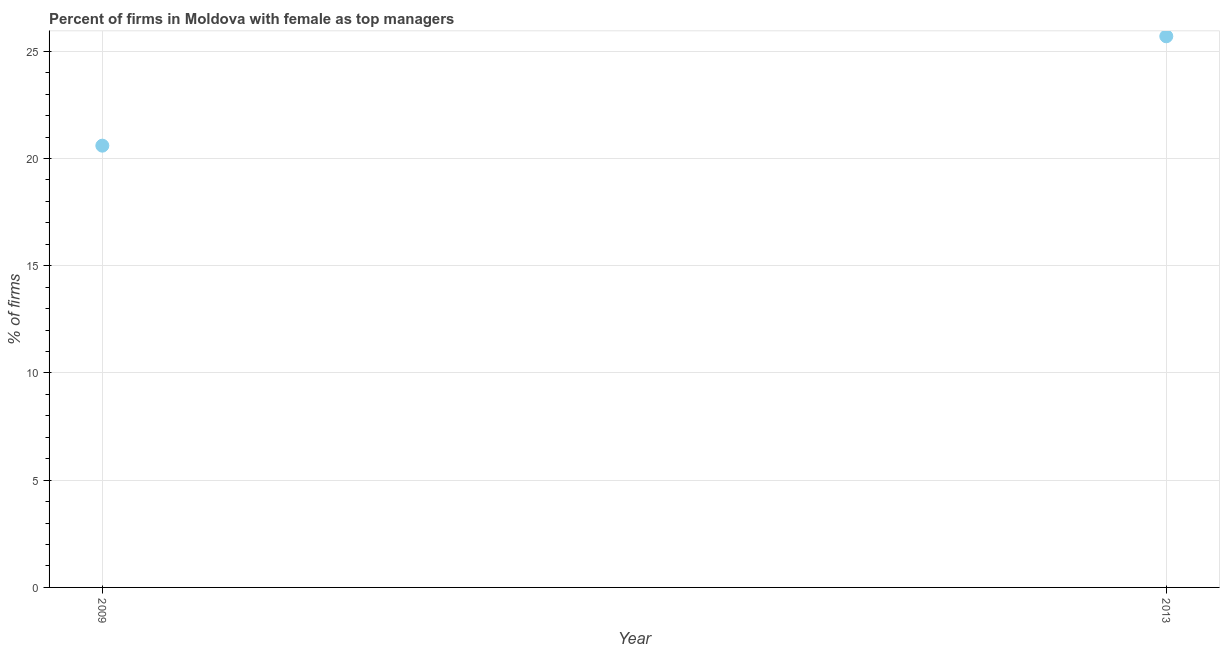What is the percentage of firms with female as top manager in 2009?
Your response must be concise. 20.6. Across all years, what is the maximum percentage of firms with female as top manager?
Provide a short and direct response. 25.7. Across all years, what is the minimum percentage of firms with female as top manager?
Give a very brief answer. 20.6. In which year was the percentage of firms with female as top manager maximum?
Offer a very short reply. 2013. What is the sum of the percentage of firms with female as top manager?
Provide a short and direct response. 46.3. What is the difference between the percentage of firms with female as top manager in 2009 and 2013?
Offer a terse response. -5.1. What is the average percentage of firms with female as top manager per year?
Your answer should be very brief. 23.15. What is the median percentage of firms with female as top manager?
Provide a short and direct response. 23.15. In how many years, is the percentage of firms with female as top manager greater than 19 %?
Ensure brevity in your answer.  2. What is the ratio of the percentage of firms with female as top manager in 2009 to that in 2013?
Ensure brevity in your answer.  0.8. In how many years, is the percentage of firms with female as top manager greater than the average percentage of firms with female as top manager taken over all years?
Give a very brief answer. 1. How many dotlines are there?
Give a very brief answer. 1. How many years are there in the graph?
Your response must be concise. 2. Are the values on the major ticks of Y-axis written in scientific E-notation?
Keep it short and to the point. No. What is the title of the graph?
Offer a very short reply. Percent of firms in Moldova with female as top managers. What is the label or title of the X-axis?
Your response must be concise. Year. What is the label or title of the Y-axis?
Your answer should be compact. % of firms. What is the % of firms in 2009?
Make the answer very short. 20.6. What is the % of firms in 2013?
Your answer should be very brief. 25.7. What is the difference between the % of firms in 2009 and 2013?
Your response must be concise. -5.1. What is the ratio of the % of firms in 2009 to that in 2013?
Keep it short and to the point. 0.8. 